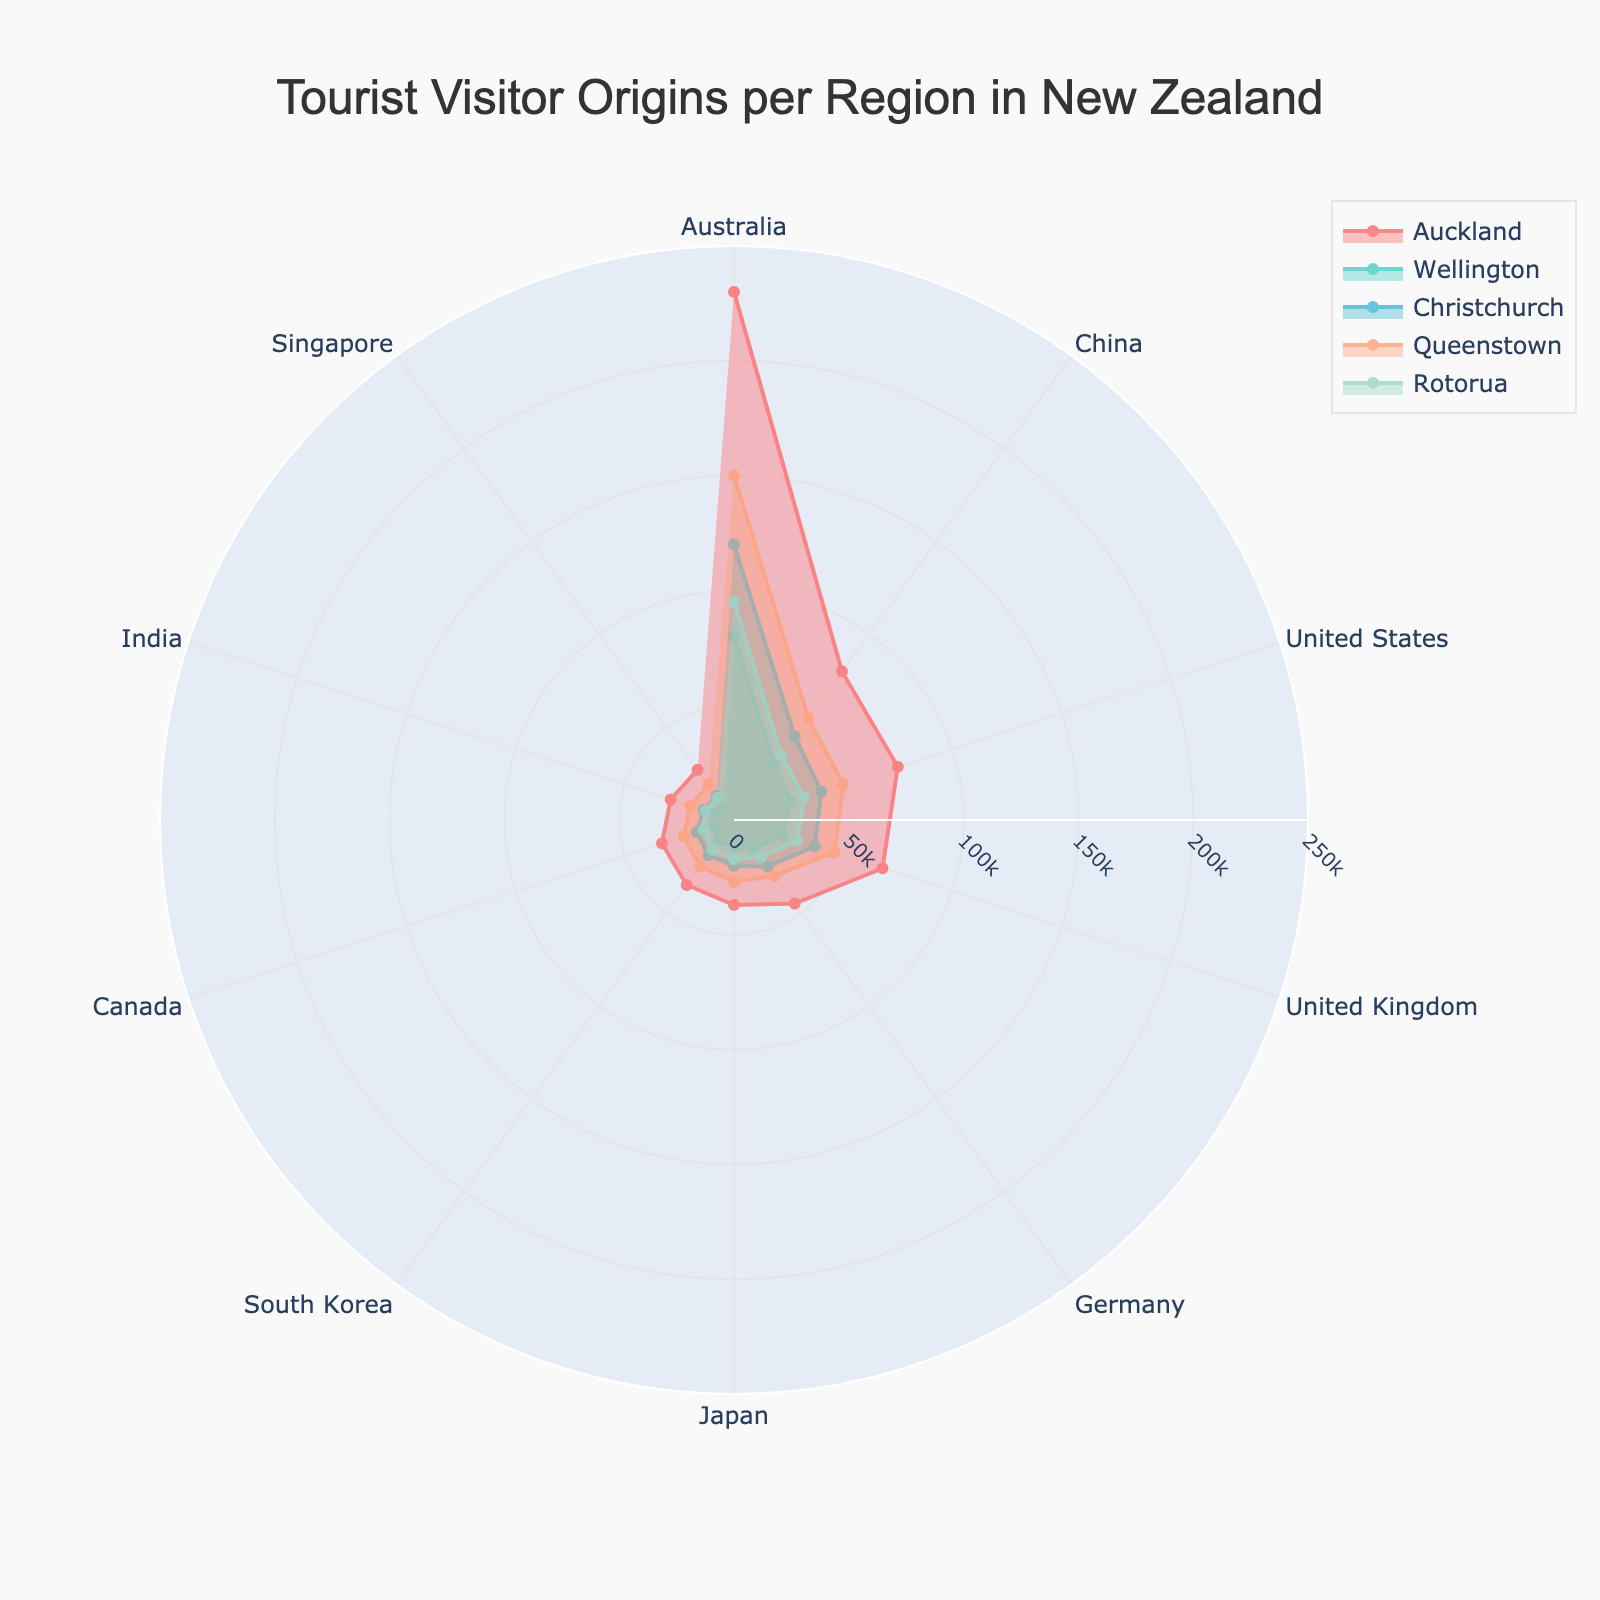What is the title of the figure? The title of the figure is displayed prominently at the top of the chart. It reads "Tourist Visitor Origins per Region in New Zealand".
Answer: Tourist Visitor Origins per Region in New Zealand Which region has the highest number of Australian tourists? The highest number of Australian tourists is represented by the region with the highest radial value in the 'Australia' category. Auckland has the highest value at 230,000.
Answer: Auckland What are the colors representing each region? The regions are represented by different colors: Auckland is red, Wellington is turquoise, Christchurch is light blue, Queenstown is light salmon, and Rotorua is light green.
Answer: Red, Turquoise, Light Blue, Light Salmon, Light Green How many regions attract more than 100,000 tourists from Australia? By examining the 'Australia' category, the regions that have radial values exceeding 100,000 are Auckland, Christchurch, and Queenstown. Thus, there are three regions.
Answer: Three Which region has the lowest number of tourists from India? By looking at the radial values in the 'India' category, Wellington has the lowest value at 8,500.
Answer: Wellington Compare the number of Chinese tourists visiting Wellington and Rotorua. Wellington has 30,000 tourists from China, and Rotorua has 35,000. Rotorua has 5,000 more tourists than Wellington.
Answer: Rotorua What’s the average number of United Kingdom tourists among all the regions? Add up the number of tourists from the United Kingdom in each region and divide by the number of regions: (68000 + 22000 + 37000 + 46000 + 29000) / 5. The result is 40,600.
Answer: 40,600 Are there more tourists from Singapore visiting Christchurch or Rotorua? By examining the 'Singapore' category, Christchurch has 13,000 tourists and Rotorua has 12,000 tourists, so more tourists from Singapore visit Christchurch.
Answer: Christchurch Which region appears to have the most balanced distribution of tourists from different countries? The region with the most balanced distribution will have similar radial values across different categories. Rotorua shows a relatively uniform distribution across all countries.
Answer: Rotorua Which region has more tourists from Japan compared to South Korea? Examine the radial values for 'Japan' and 'South Korea' categories for each region. In Wellington, Japan has 12,000 and South Korea has 11,000, making Wellington the region where Japan has more tourists compared to South Korea.
Answer: Wellington 